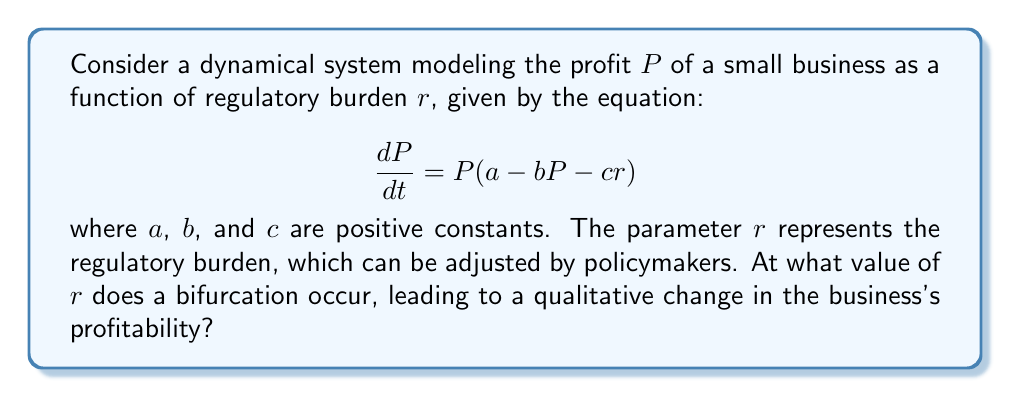Teach me how to tackle this problem. To solve this problem, we'll follow these steps:

1) First, we need to find the equilibrium points of the system. These occur when $\frac{dP}{dt} = 0$:

   $$P(a - bP - cr) = 0$$

2) This equation has two solutions:
   
   $P = 0$ or $a - bP - cr = 0$

3) The non-zero equilibrium point is given by:

   $$P^* = \frac{a - cr}{b}$$

4) A bifurcation occurs when the stability of the equilibrium points changes. In this case, it happens when the non-zero equilibrium point $P^*$ becomes negative, which causes it to collide with the zero equilibrium point.

5) The bifurcation point is where $P^* = 0$:

   $$\frac{a - cr}{b} = 0$$

6) Solving this equation for $r$:

   $$a - cr = 0$$
   $$cr = a$$
   $$r = \frac{a}{c}$$

7) Therefore, the bifurcation occurs at $r = \frac{a}{c}$.

8) When $r < \frac{a}{c}$, the non-zero equilibrium point is positive and stable, representing a profitable business. When $r > \frac{a}{c}$, only the zero equilibrium is relevant, representing a business that cannot sustain profitability.

This bifurcation represents a critical point where increased regulatory burden causes a qualitative change in the business's ability to maintain profitability.
Answer: $r = \frac{a}{c}$ 